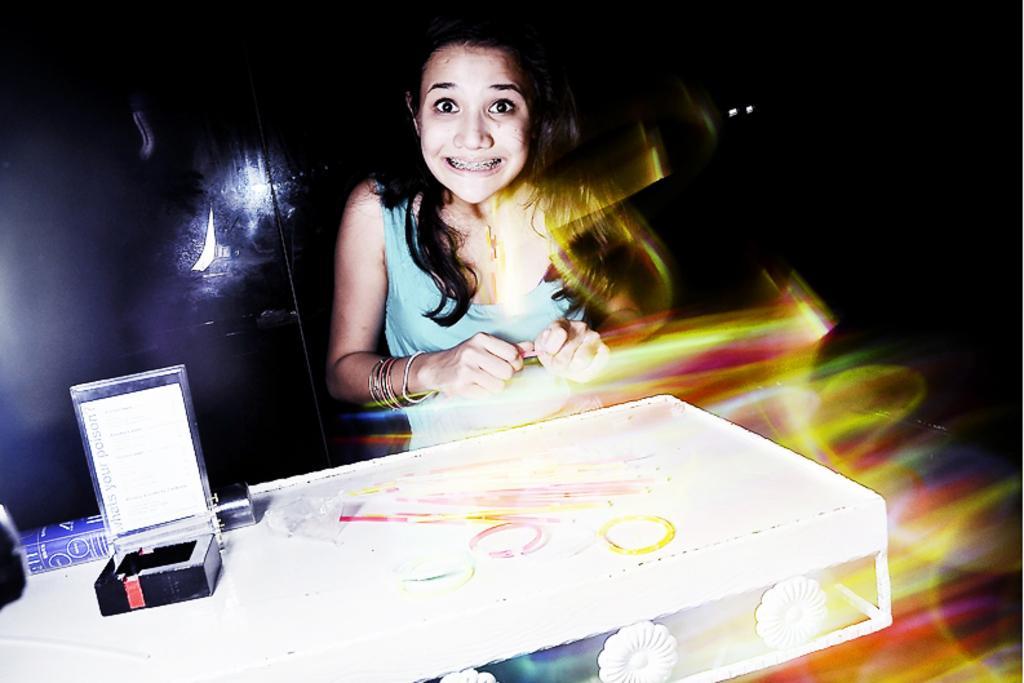Could you give a brief overview of what you see in this image? In the picture we can see a woman standing and holding something, she is with blue top and showing her teeth and in front of her we can see white color table on it, we can see a small box with a card and some information on it and behind the woman we can see a wall which is black in color. 